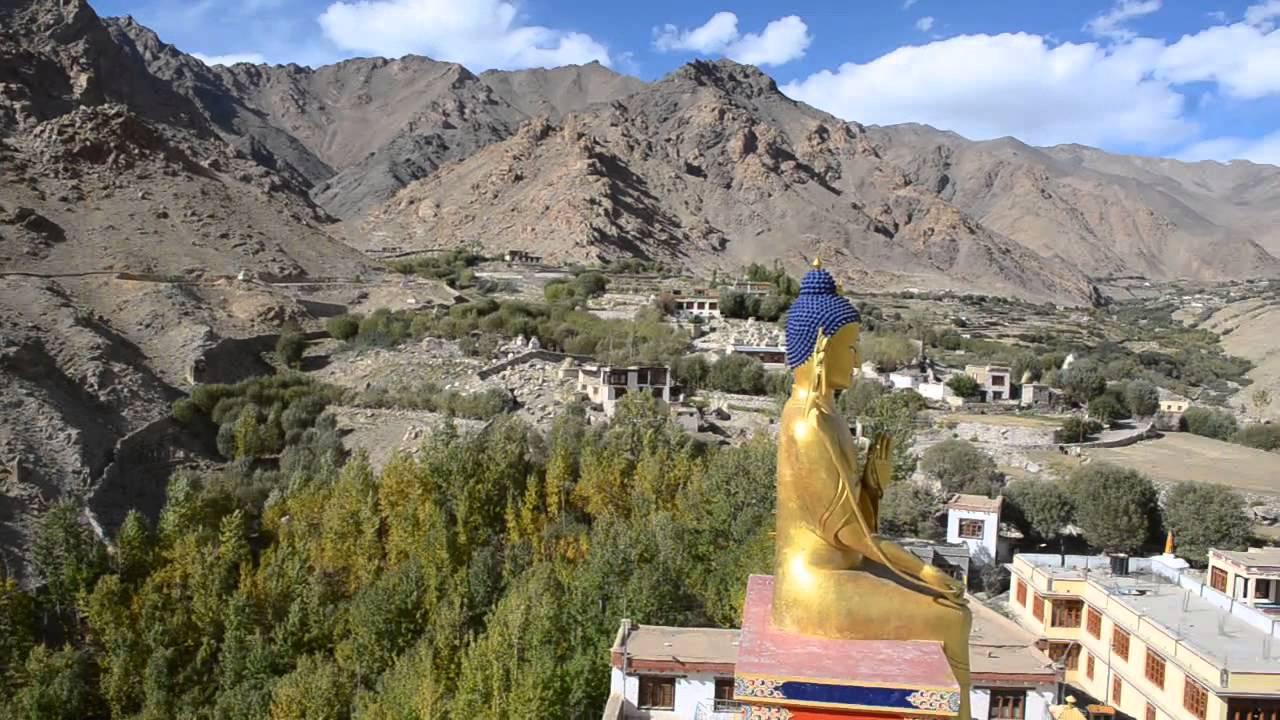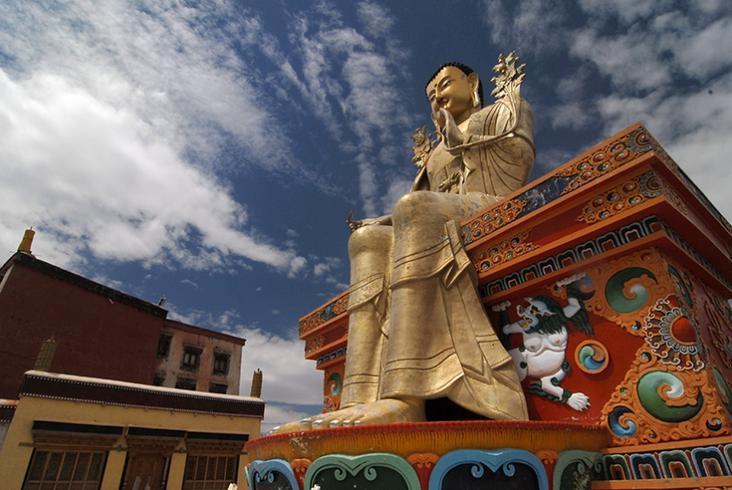The first image is the image on the left, the second image is the image on the right. For the images shown, is this caption "A large golden shrine in the image of a person can be seen in both images." true? Answer yes or no. Yes. The first image is the image on the left, the second image is the image on the right. Given the left and right images, does the statement "An image includes a golden seated figure with blue hair." hold true? Answer yes or no. Yes. 